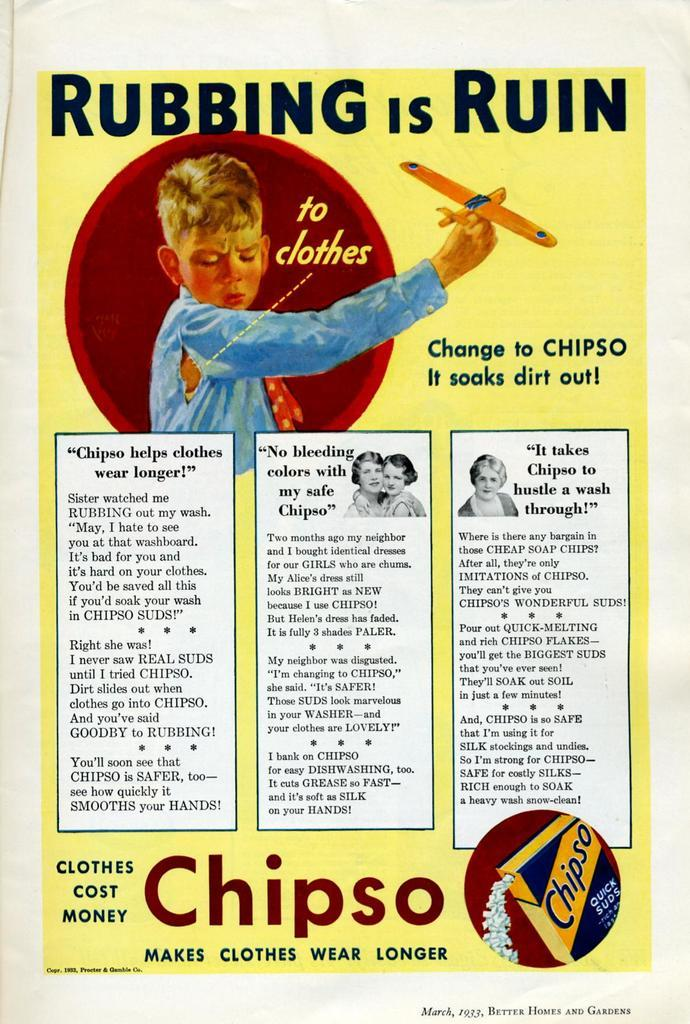What is featured in the image? There is a poster in the image. What can be found on the poster? The poster contains text and a person. Can you describe the person in the poster? The person is wearing a blue dress and holding an aircraft in their hands. What type of vegetable is being held by the person in the poster? There is no vegetable present in the image; the person is holding an aircraft. Is the person in the poster turning on a light bulb? There is no light bulb present in the image; the person is holding an aircraft. 